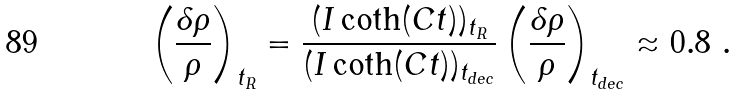<formula> <loc_0><loc_0><loc_500><loc_500>\left ( \frac { \delta \rho } { \rho } \right ) _ { t _ { R } } = \frac { ( I \coth ( C t ) ) _ { t _ { R } } } { ( I \coth ( C t ) ) _ { t _ { d e c } } } \left ( \frac { \delta \rho } { \rho } \right ) _ { t _ { d e c } } \approx 0 . 8 \ .</formula> 